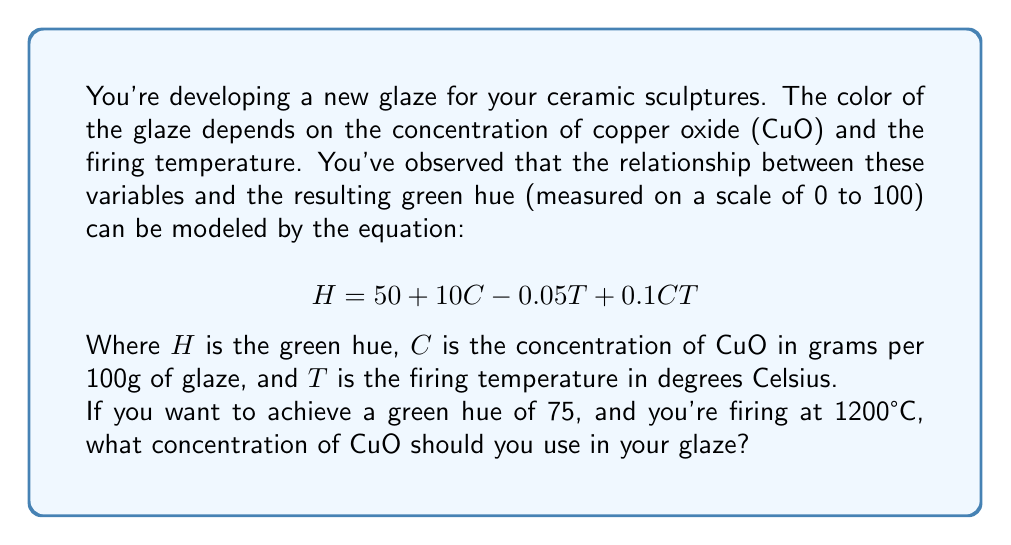Can you solve this math problem? Let's approach this step-by-step:

1) We're given the equation:
   $$H = 50 + 10C - 0.05T + 0.1CT$$

2) We know the desired hue ($H$) and the firing temperature ($T$):
   $H = 75$
   $T = 1200$

3) Let's substitute these values into our equation:
   $$75 = 50 + 10C - 0.05(1200) + 0.1C(1200)$$

4) Simplify the constant terms:
   $$75 = 50 + 10C - 60 + 120C$$
   $$75 = -10 + 10C + 120C$$

5) Combine like terms:
   $$75 = -10 + 130C$$

6) Add 10 to both sides:
   $$85 = 130C$$

7) Divide both sides by 130:
   $$\frac{85}{130} = C$$

8) Simplify:
   $$C \approx 0.6538$$

Therefore, you should use approximately 0.6538 grams of CuO per 100g of glaze to achieve a green hue of 75 when firing at 1200°C.
Answer: $0.6538$ g CuO per 100g glaze 